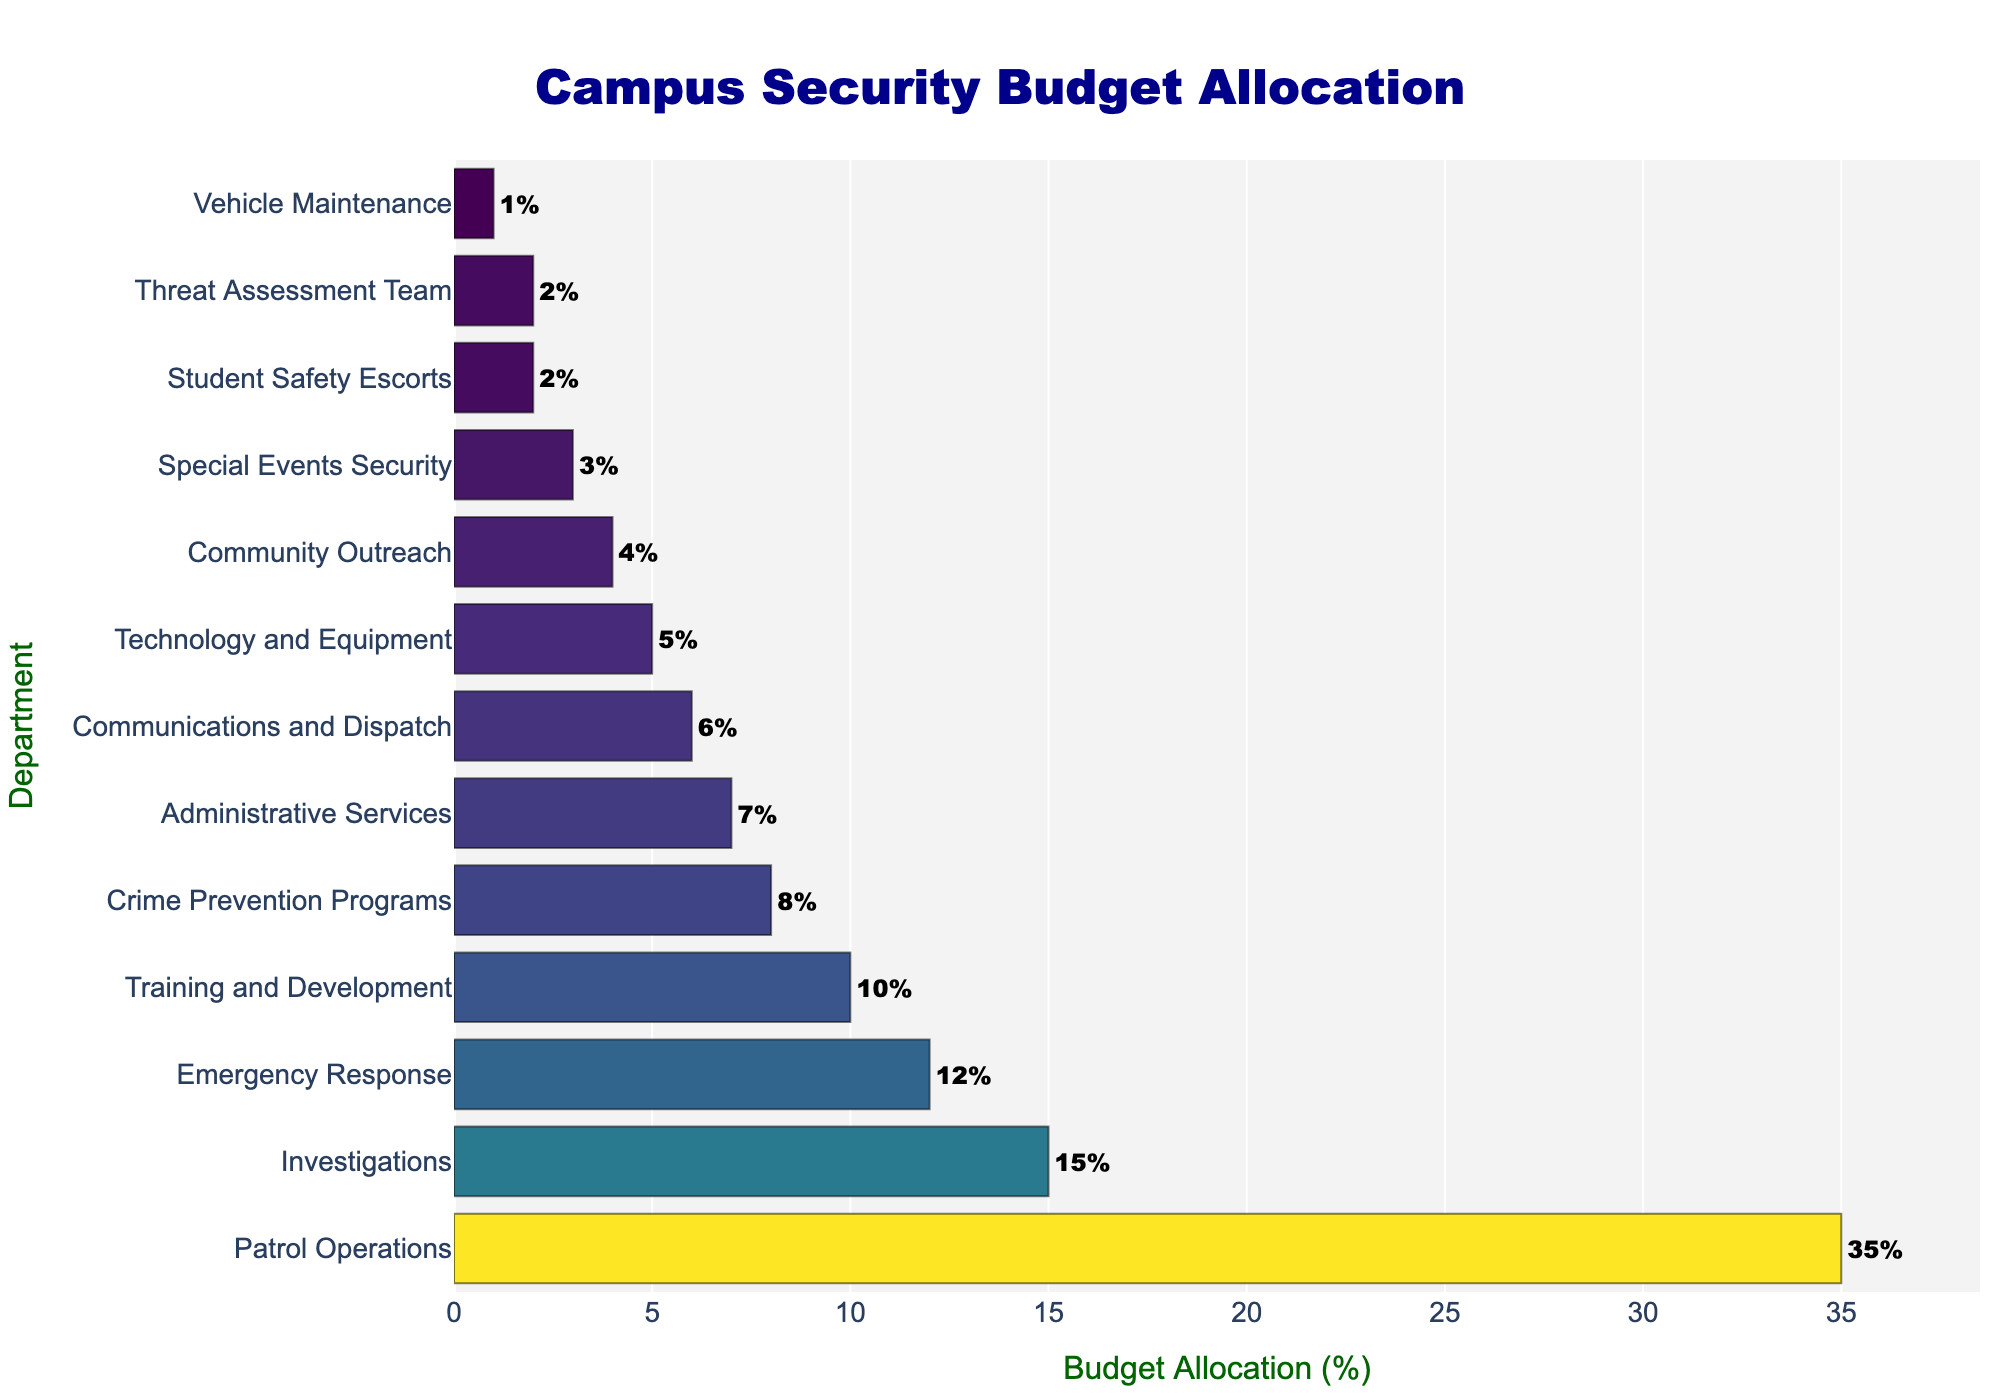which department has the highest budget allocation? The bar graph shows the Patrol Operations department has the longest bar, indicating it has the largest allocation of 35%.
Answer: Patrol Operations What is the total budget allocation for Emergency Response and Crime Prevention Programs combined? The budget for Emergency Response is 12% and for Crime Prevention Programs is 8%. Adding these together gives 12% + 8% = 20%.
Answer: 20% Which department has a lower budget allocation: Training and Development or Communications and Dispatch? By comparing the bars, we see that the Training and Development department is allocated 10%, whereas Communications and Dispatch is allocated 6%. Since 6% < 10%, Communications and Dispatch has a lower budget.
Answer: Communications and Dispatch How much more budget allocation does Patrol Operations have compared to the Threat Assessment Team? Patrol Operations has 35% and the Threat Assessment Team has 2%. The difference is 35% - 2% = 33%.
Answer: 33% Which department has the smallest budget allocation? The smallest bar corresponds to Vehicle Maintenance with a budget allocation of 1%.
Answer: Vehicle Maintenance How much is the combined budget for departments that focus on student and community safety: Community Outreach and Student Safety Escorts? Community Outreach has a budget of 4% and Student Safety Escorts has 2%. Adding these together, 4% + 2% = 6%.
Answer: 6% What is the median budget allocation across all departments? To find the median, we must list all budget allocations in order: 1%, 2%, 2%, 3%, 4%, 5%, 6%, 7%, 8%, 10%, 12%, 15%, 35%. The middle value in this ordered list is 6%.
Answer: 6% By how much does the budget allocation for Special Events Security differ from Technology and Equipment? Special Events Security has 3%, and Technology and Equipment has 5%. The difference is 5% - 3% = 2%.
Answer: 2% Which has a larger budget: Administrative Services or Investigations? By comparing bar lengths, Investigations has 15% while Administrative Services has 7%. Since 15% > 7%, Investigations has a larger budget.
Answer: Investigations 